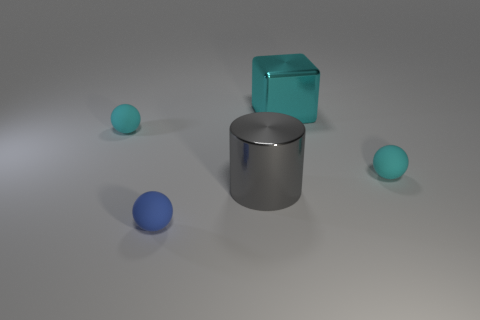Add 3 small gray balls. How many objects exist? 8 Subtract all cylinders. How many objects are left? 4 Subtract all tiny yellow blocks. Subtract all gray things. How many objects are left? 4 Add 1 tiny cyan objects. How many tiny cyan objects are left? 3 Add 2 tiny matte things. How many tiny matte things exist? 5 Subtract 0 brown blocks. How many objects are left? 5 